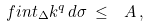<formula> <loc_0><loc_0><loc_500><loc_500>\ f i n t _ { \Delta } k ^ { q } \, d \sigma \, \leq \, \ A \, ,</formula> 